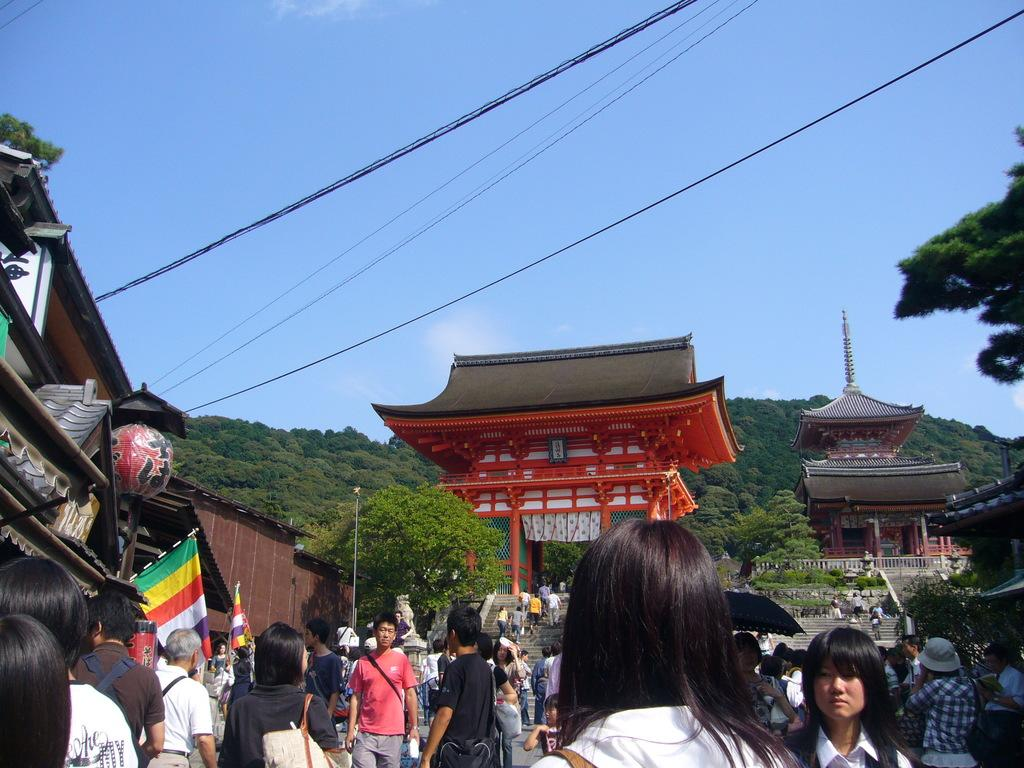What can be seen in the foreground of the image? There are people in the foreground of the image. What type of structures are present in the image? There are buildings in the image. What additional objects can be seen in the image? There are flags and a model of a ball in the image. What is visible in the background of the image? The background of the image appears to include mountains and the sky. How does the crow interact with the loaf in the image? There is no crow or loaf present in the image. What impulse might the people in the image be experiencing? We cannot determine the impulses of the people in the image based on the provided facts. 